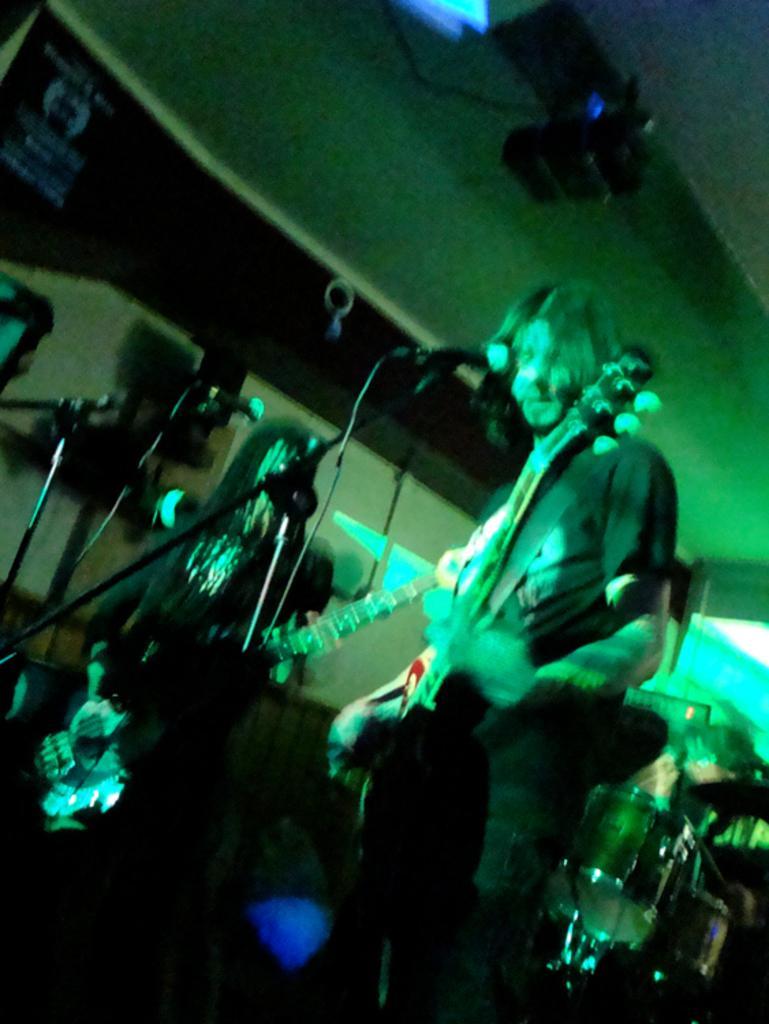Could you give a brief overview of what you see in this image? In this picture there is a boy wearing black color t-shirt, standing and playing the guitar. Behind there is a another boy playing guitar. In the background there is a music band and on the top we can see the projector and green lights. 